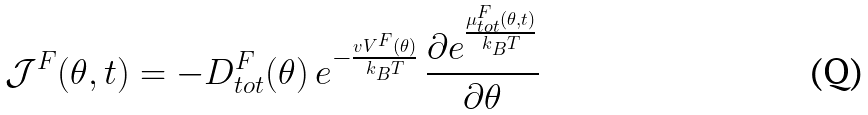Convert formula to latex. <formula><loc_0><loc_0><loc_500><loc_500>\mathcal { J } ^ { F } ( \theta , t ) = - D _ { t o t } ^ { F } ( \theta ) \, e ^ { - \frac { v V ^ { F } ( \theta ) } { k _ { B } T } } \, \frac { \partial e ^ { \frac { \mu ^ { F } _ { t o t } ( \theta , t ) } { k _ { B } T } } } { \partial \theta }</formula> 